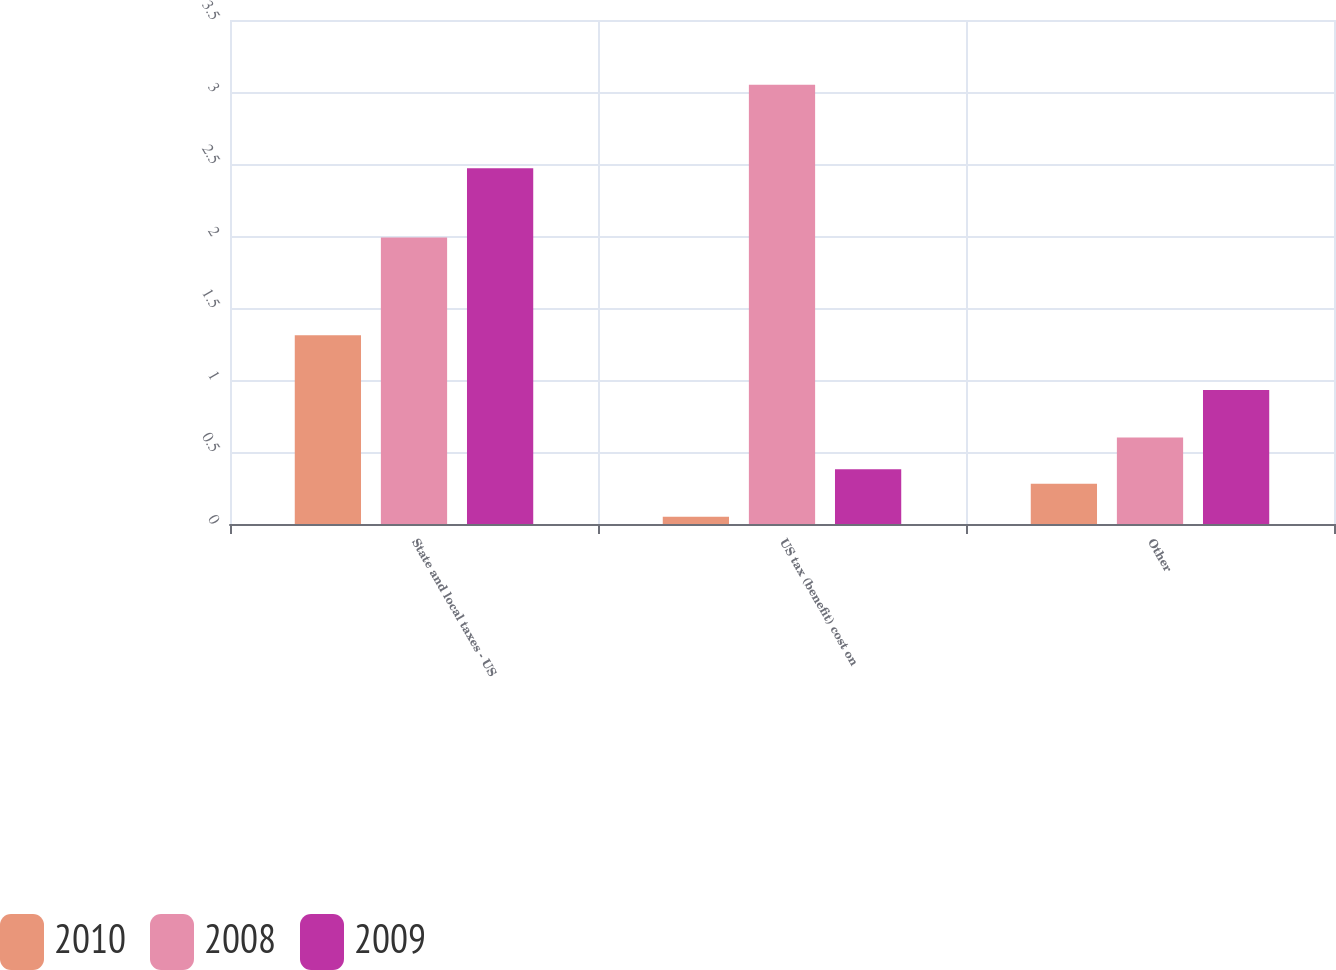Convert chart to OTSL. <chart><loc_0><loc_0><loc_500><loc_500><stacked_bar_chart><ecel><fcel>State and local taxes - US<fcel>US tax (benefit) cost on<fcel>Other<nl><fcel>2010<fcel>1.31<fcel>0.05<fcel>0.28<nl><fcel>2008<fcel>1.99<fcel>3.05<fcel>0.6<nl><fcel>2009<fcel>2.47<fcel>0.38<fcel>0.93<nl></chart> 